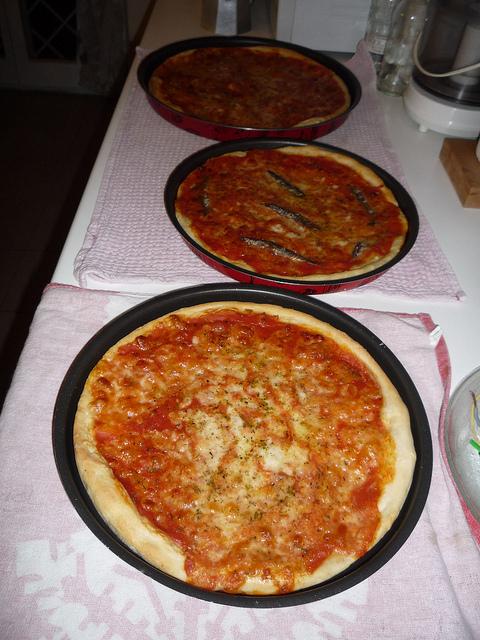Are the pizzas the same shape?
Be succinct. Yes. Is the towel in front upside down?
Be succinct. Yes. Is this a deep dish pizza?
Be succinct. No. Is there a cell phone in the picture?
Give a very brief answer. No. What design does the tablecloth have?
Answer briefly. Solid. How many pizzas are here?
Quick response, please. 3. What color is the plate?
Answer briefly. Black. What kind of pizza's are these?
Be succinct. Cheese. How many pizzas is for dinner?
Answer briefly. 3. 